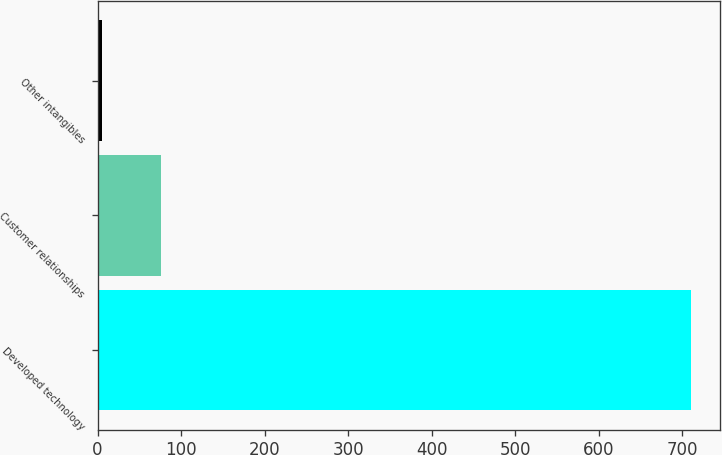Convert chart. <chart><loc_0><loc_0><loc_500><loc_500><bar_chart><fcel>Developed technology<fcel>Customer relationships<fcel>Other intangibles<nl><fcel>710<fcel>75.5<fcel>5<nl></chart> 